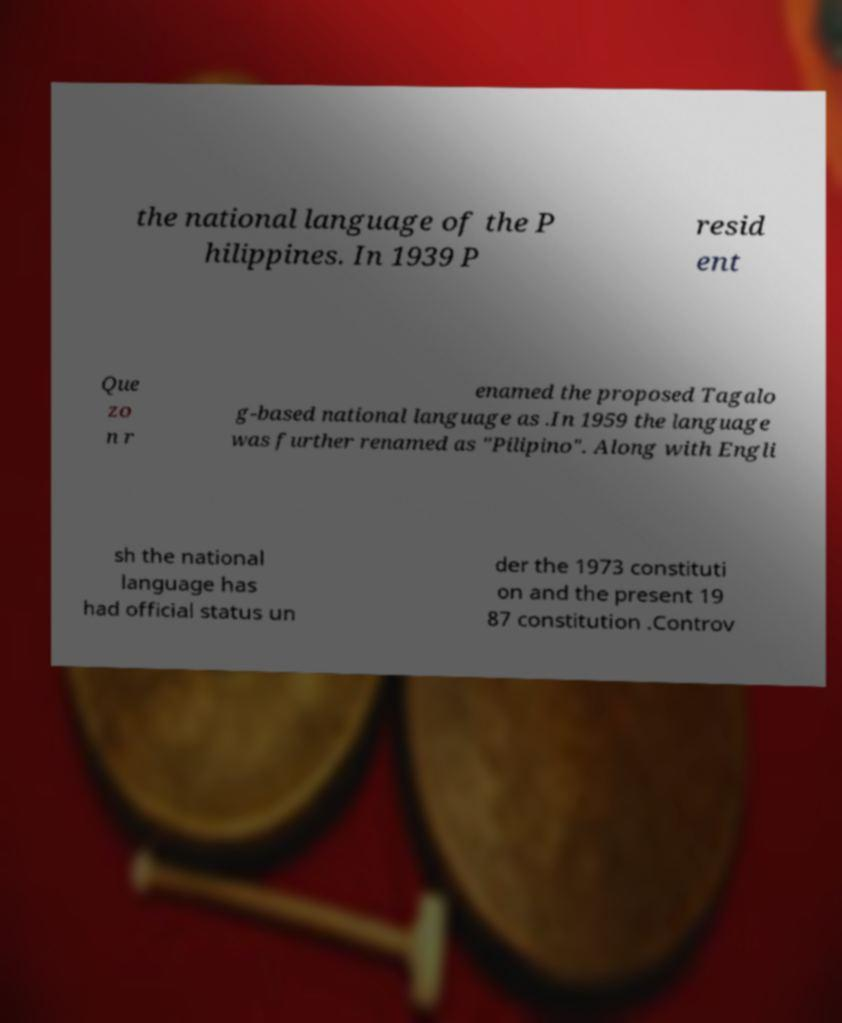There's text embedded in this image that I need extracted. Can you transcribe it verbatim? the national language of the P hilippines. In 1939 P resid ent Que zo n r enamed the proposed Tagalo g-based national language as .In 1959 the language was further renamed as "Pilipino". Along with Engli sh the national language has had official status un der the 1973 constituti on and the present 19 87 constitution .Controv 